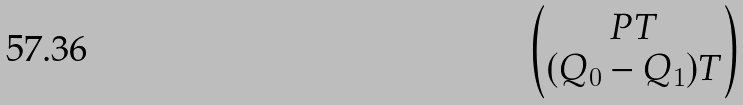Convert formula to latex. <formula><loc_0><loc_0><loc_500><loc_500>\begin{pmatrix} P T \\ ( Q _ { 0 } - Q _ { 1 } ) T \end{pmatrix}</formula> 